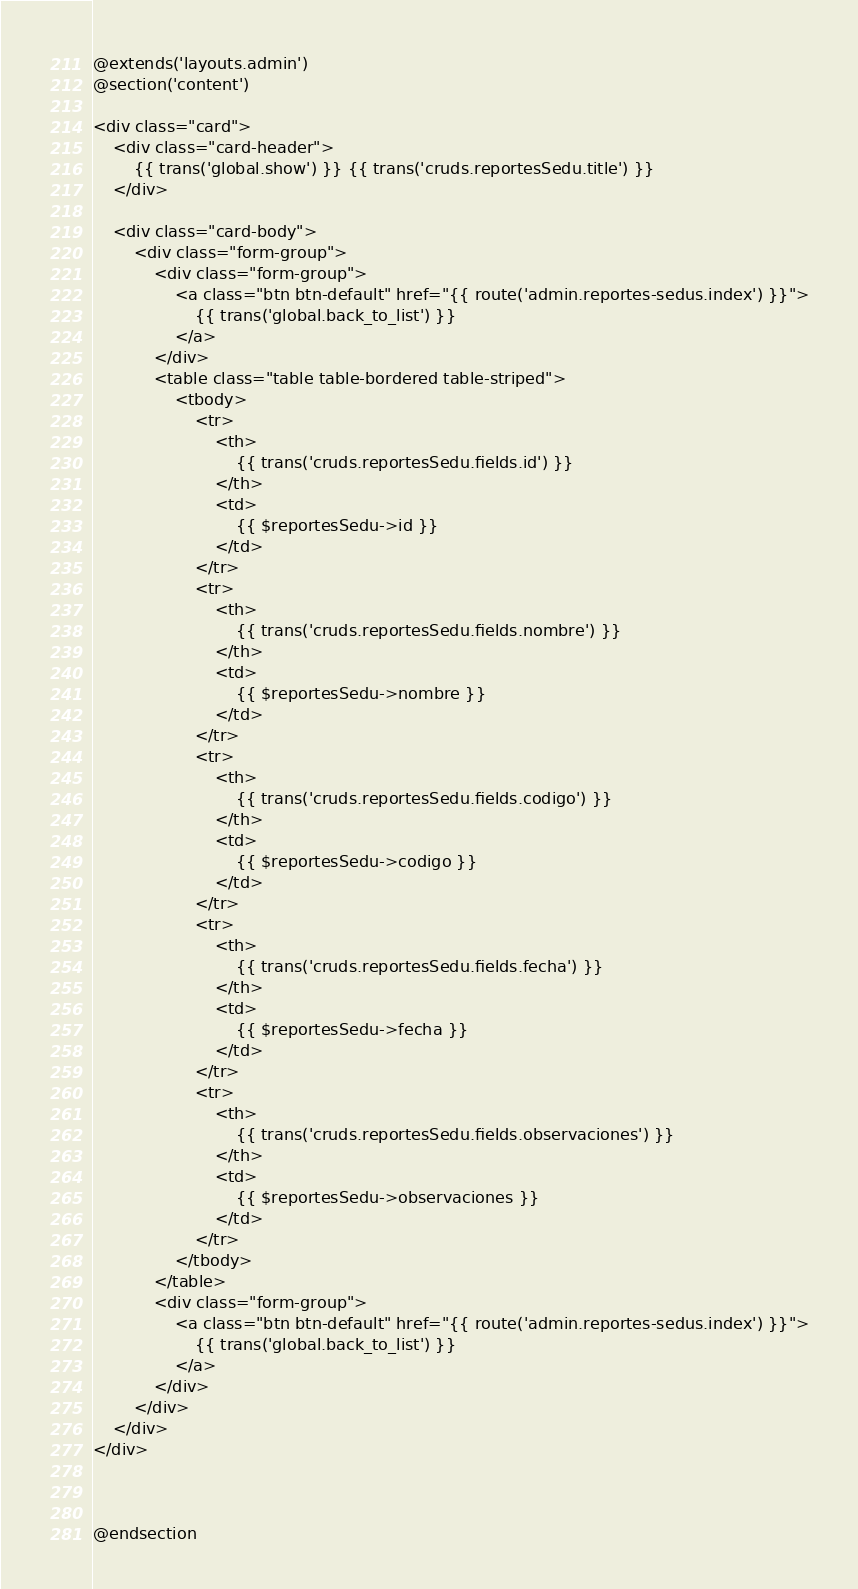<code> <loc_0><loc_0><loc_500><loc_500><_PHP_>@extends('layouts.admin')
@section('content')

<div class="card">
    <div class="card-header">
        {{ trans('global.show') }} {{ trans('cruds.reportesSedu.title') }}
    </div>

    <div class="card-body">
        <div class="form-group">
            <div class="form-group">
                <a class="btn btn-default" href="{{ route('admin.reportes-sedus.index') }}">
                    {{ trans('global.back_to_list') }}
                </a>
            </div>
            <table class="table table-bordered table-striped">
                <tbody>
                    <tr>
                        <th>
                            {{ trans('cruds.reportesSedu.fields.id') }}
                        </th>
                        <td>
                            {{ $reportesSedu->id }}
                        </td>
                    </tr>
                    <tr>
                        <th>
                            {{ trans('cruds.reportesSedu.fields.nombre') }}
                        </th>
                        <td>
                            {{ $reportesSedu->nombre }}
                        </td>
                    </tr>
                    <tr>
                        <th>
                            {{ trans('cruds.reportesSedu.fields.codigo') }}
                        </th>
                        <td>
                            {{ $reportesSedu->codigo }}
                        </td>
                    </tr>
                    <tr>
                        <th>
                            {{ trans('cruds.reportesSedu.fields.fecha') }}
                        </th>
                        <td>
                            {{ $reportesSedu->fecha }}
                        </td>
                    </tr>
                    <tr>
                        <th>
                            {{ trans('cruds.reportesSedu.fields.observaciones') }}
                        </th>
                        <td>
                            {{ $reportesSedu->observaciones }}
                        </td>
                    </tr>
                </tbody>
            </table>
            <div class="form-group">
                <a class="btn btn-default" href="{{ route('admin.reportes-sedus.index') }}">
                    {{ trans('global.back_to_list') }}
                </a>
            </div>
        </div>
    </div>
</div>



@endsection</code> 